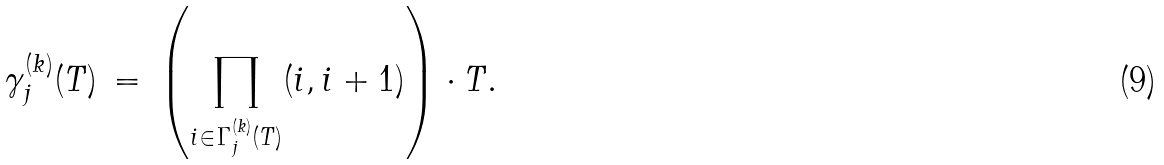<formula> <loc_0><loc_0><loc_500><loc_500>\gamma _ { j } ^ { ( k ) } ( T ) \, = \, \left ( \prod _ { i \in \Gamma _ { j } ^ { ( k ) } ( T ) } ( i , i + 1 ) \right ) \cdot T .</formula> 